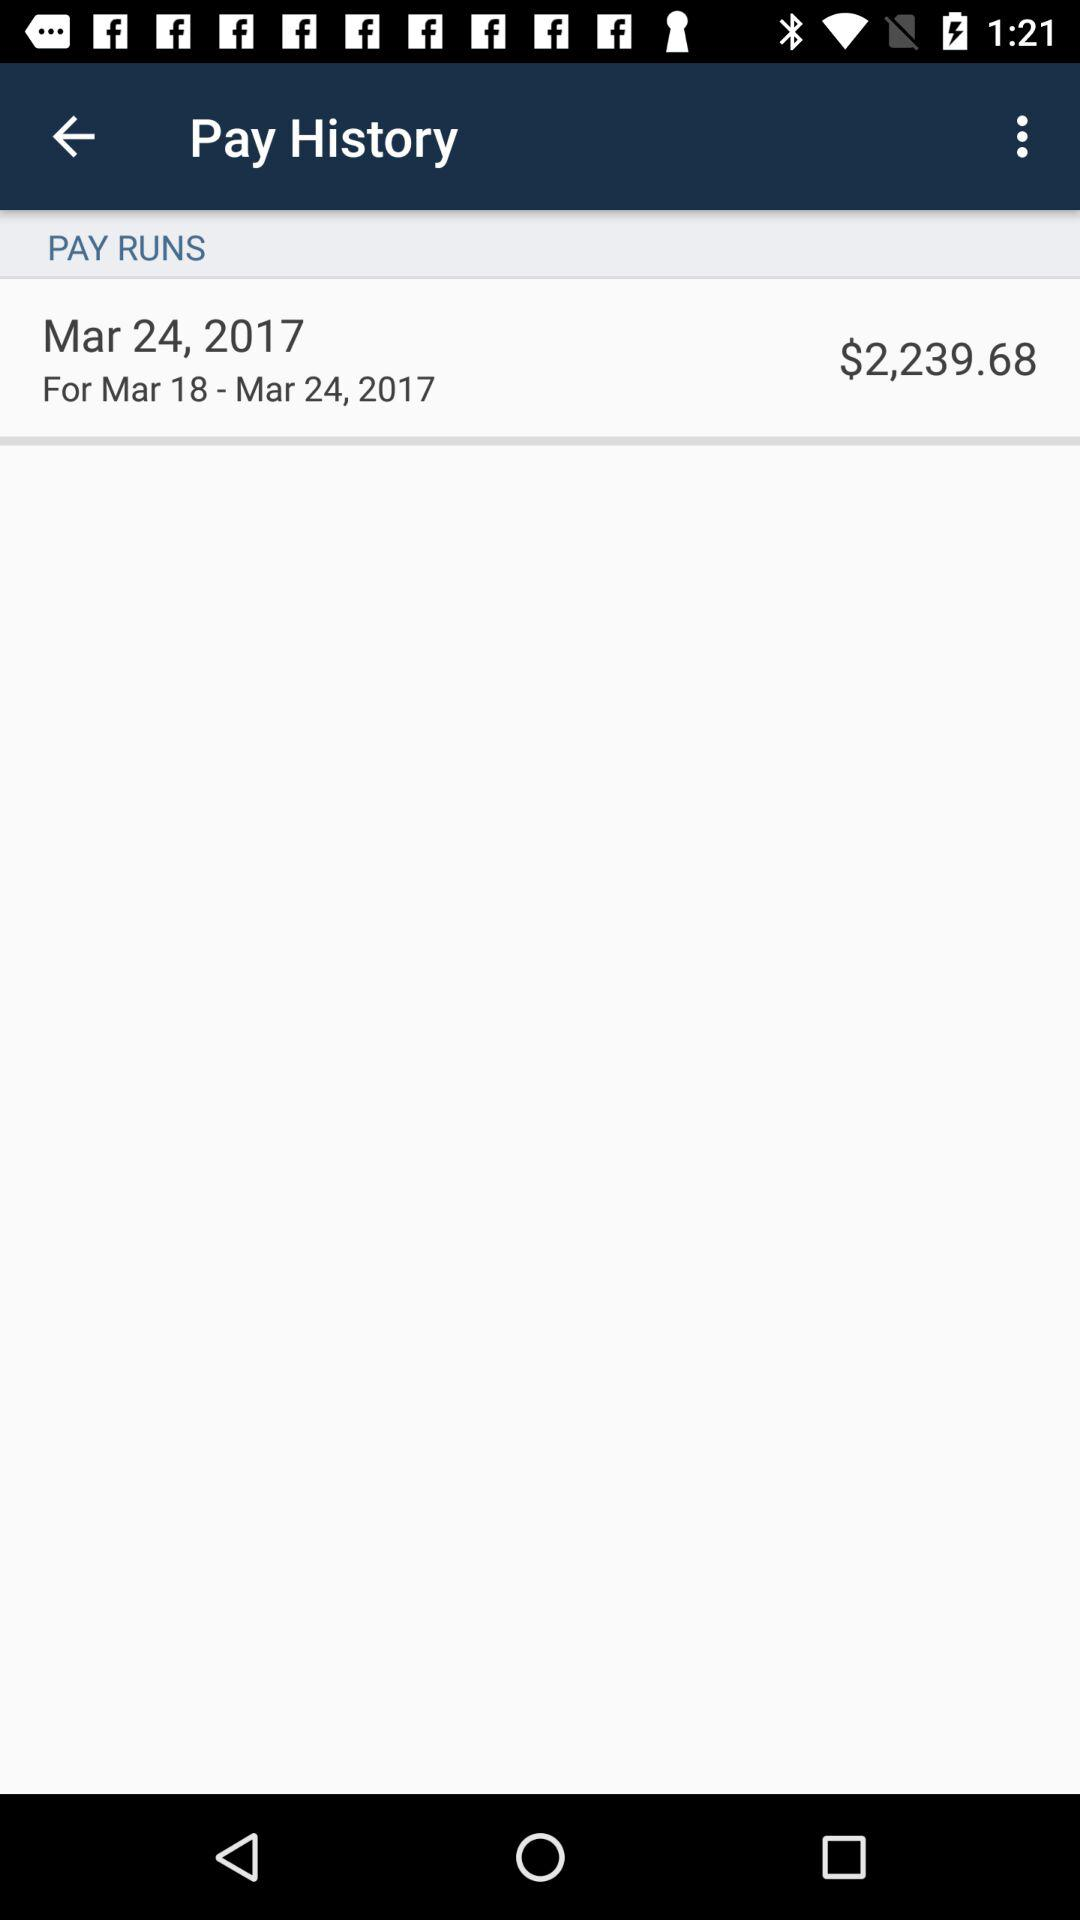What is the date of the payment? The date of the payment is March 24, 2017. 